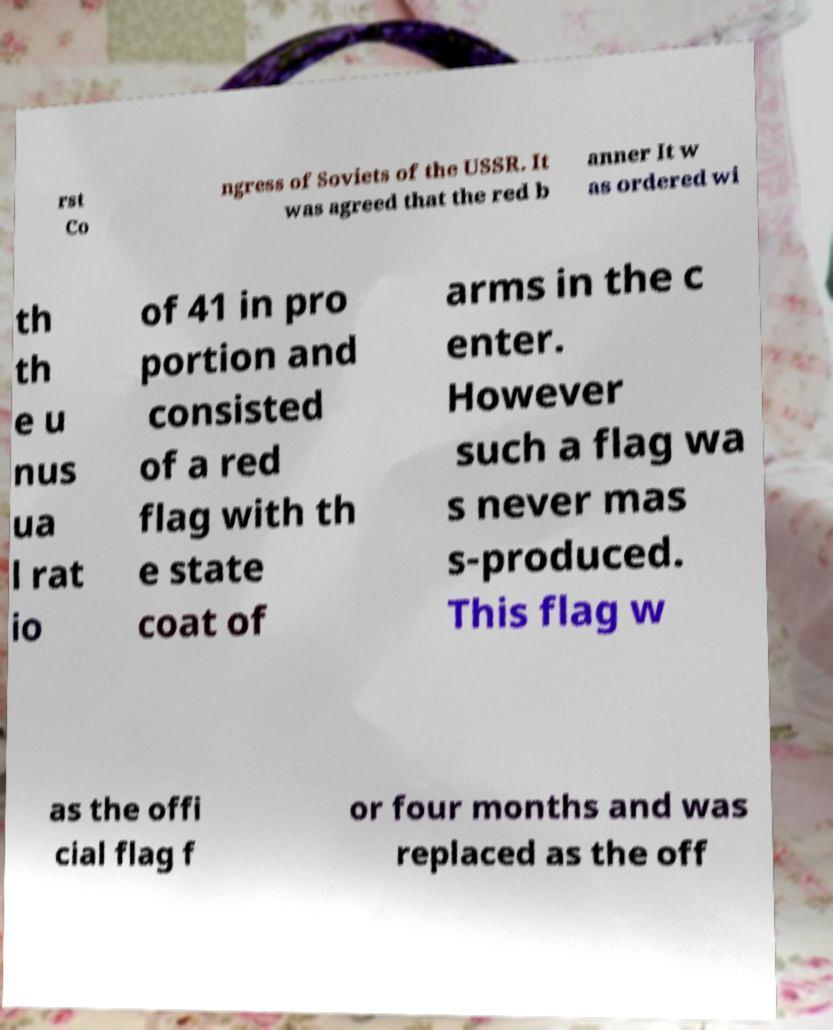Please read and relay the text visible in this image. What does it say? rst Co ngress of Soviets of the USSR. It was agreed that the red b anner It w as ordered wi th th e u nus ua l rat io of 41 in pro portion and consisted of a red flag with th e state coat of arms in the c enter. However such a flag wa s never mas s-produced. This flag w as the offi cial flag f or four months and was replaced as the off 